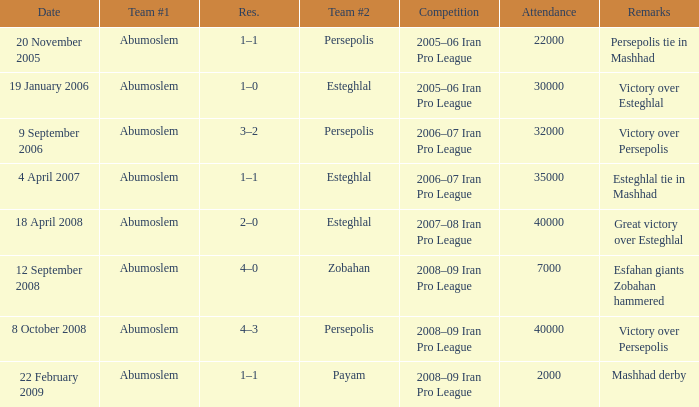What was the largest attendance? 40000.0. Could you parse the entire table as a dict? {'header': ['Date', 'Team #1', 'Res.', 'Team #2', 'Competition', 'Attendance', 'Remarks'], 'rows': [['20 November 2005', 'Abumoslem', '1–1', 'Persepolis', '2005–06 Iran Pro League', '22000', 'Persepolis tie in Mashhad'], ['19 January 2006', 'Abumoslem', '1–0', 'Esteghlal', '2005–06 Iran Pro League', '30000', 'Victory over Esteghlal'], ['9 September 2006', 'Abumoslem', '3–2', 'Persepolis', '2006–07 Iran Pro League', '32000', 'Victory over Persepolis'], ['4 April 2007', 'Abumoslem', '1–1', 'Esteghlal', '2006–07 Iran Pro League', '35000', 'Esteghlal tie in Mashhad'], ['18 April 2008', 'Abumoslem', '2–0', 'Esteghlal', '2007–08 Iran Pro League', '40000', 'Great victory over Esteghlal'], ['12 September 2008', 'Abumoslem', '4–0', 'Zobahan', '2008–09 Iran Pro League', '7000', 'Esfahan giants Zobahan hammered'], ['8 October 2008', 'Abumoslem', '4–3', 'Persepolis', '2008–09 Iran Pro League', '40000', 'Victory over Persepolis'], ['22 February 2009', 'Abumoslem', '1–1', 'Payam', '2008–09 Iran Pro League', '2000', 'Mashhad derby']]} 